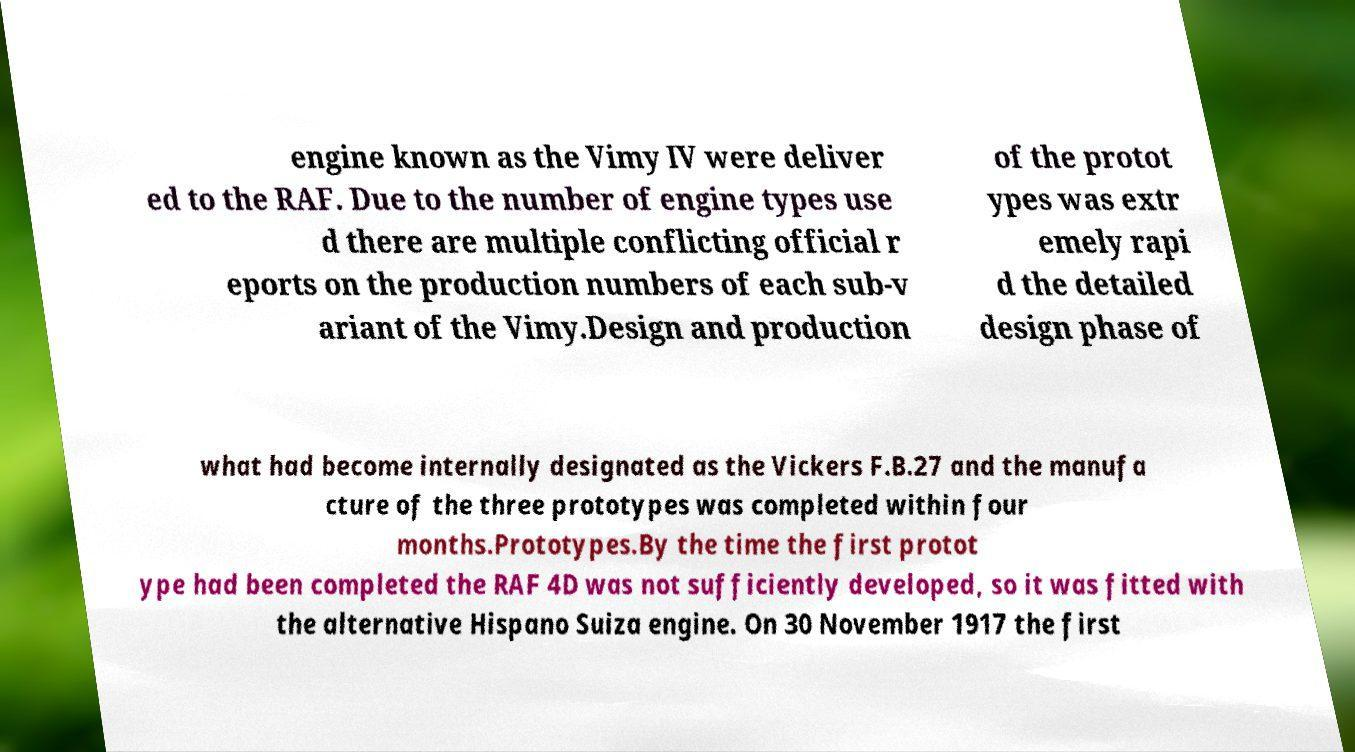Could you assist in decoding the text presented in this image and type it out clearly? engine known as the Vimy IV were deliver ed to the RAF. Due to the number of engine types use d there are multiple conflicting official r eports on the production numbers of each sub-v ariant of the Vimy.Design and production of the protot ypes was extr emely rapi d the detailed design phase of what had become internally designated as the Vickers F.B.27 and the manufa cture of the three prototypes was completed within four months.Prototypes.By the time the first protot ype had been completed the RAF 4D was not sufficiently developed, so it was fitted with the alternative Hispano Suiza engine. On 30 November 1917 the first 